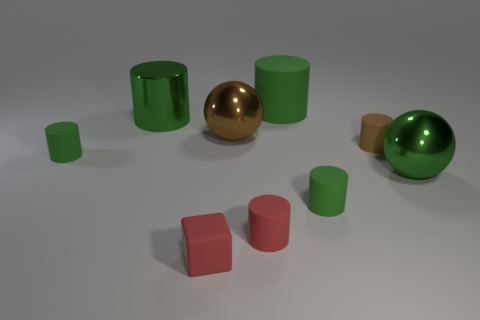Are there any large green metal spheres on the left side of the large green metallic thing that is behind the big green metal ball? no 